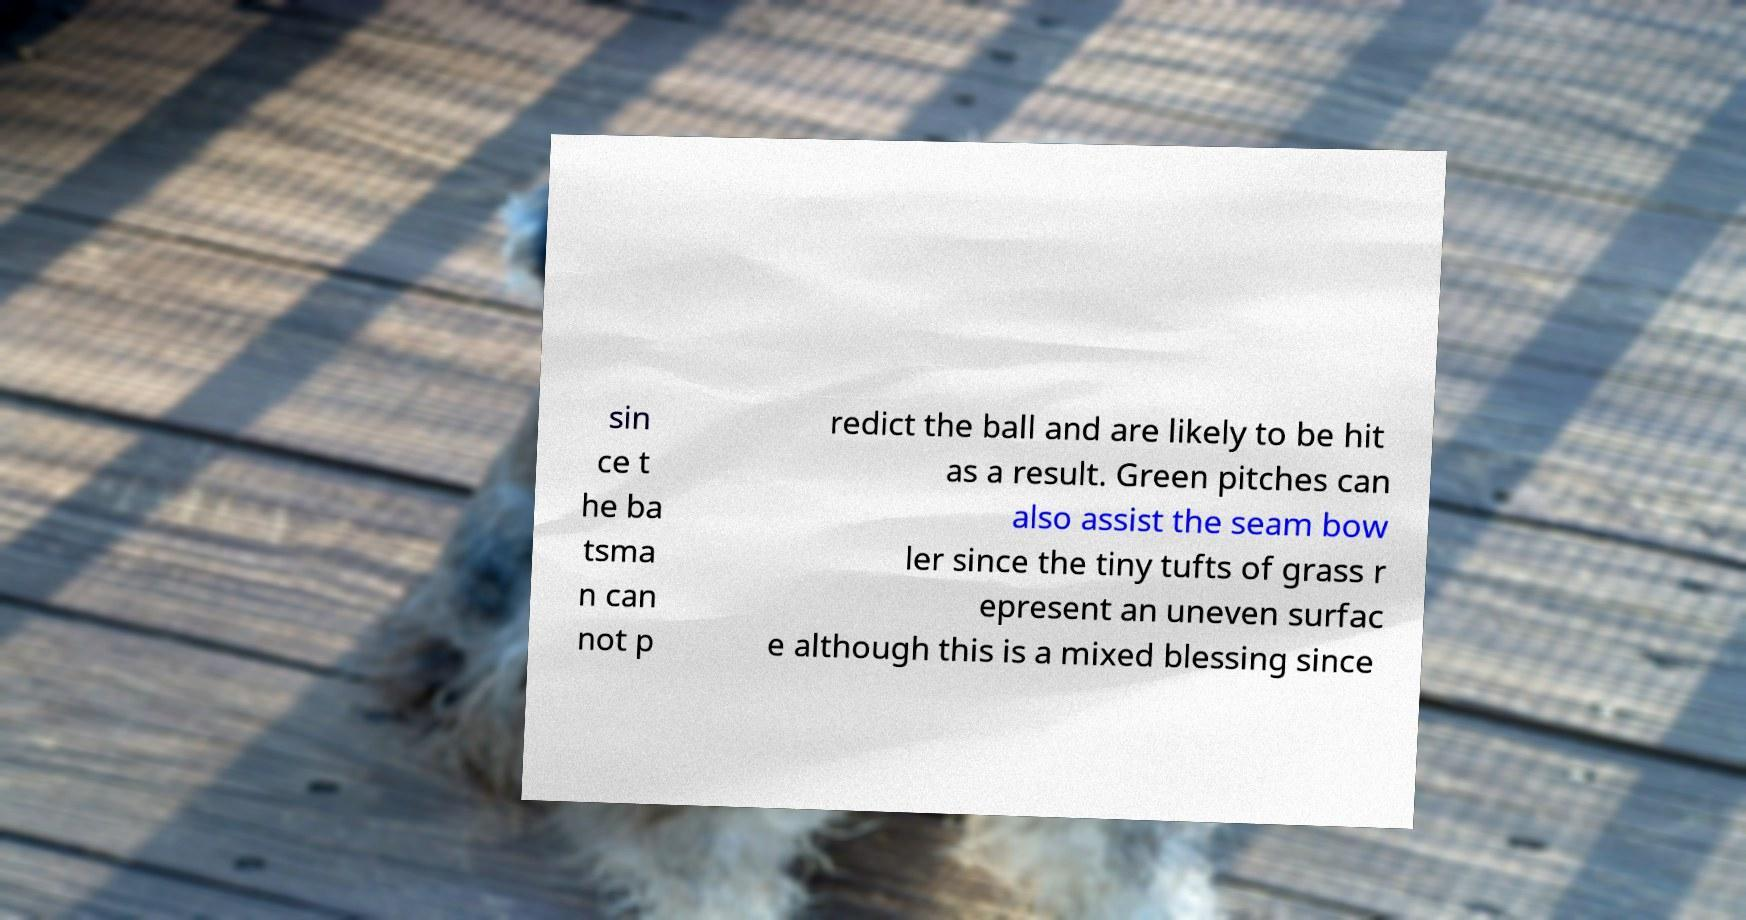Please read and relay the text visible in this image. What does it say? sin ce t he ba tsma n can not p redict the ball and are likely to be hit as a result. Green pitches can also assist the seam bow ler since the tiny tufts of grass r epresent an uneven surfac e although this is a mixed blessing since 